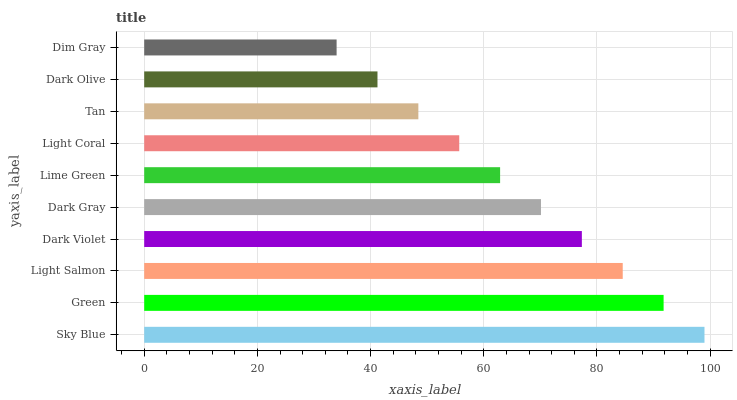Is Dim Gray the minimum?
Answer yes or no. Yes. Is Sky Blue the maximum?
Answer yes or no. Yes. Is Green the minimum?
Answer yes or no. No. Is Green the maximum?
Answer yes or no. No. Is Sky Blue greater than Green?
Answer yes or no. Yes. Is Green less than Sky Blue?
Answer yes or no. Yes. Is Green greater than Sky Blue?
Answer yes or no. No. Is Sky Blue less than Green?
Answer yes or no. No. Is Dark Gray the high median?
Answer yes or no. Yes. Is Lime Green the low median?
Answer yes or no. Yes. Is Light Salmon the high median?
Answer yes or no. No. Is Dark Violet the low median?
Answer yes or no. No. 